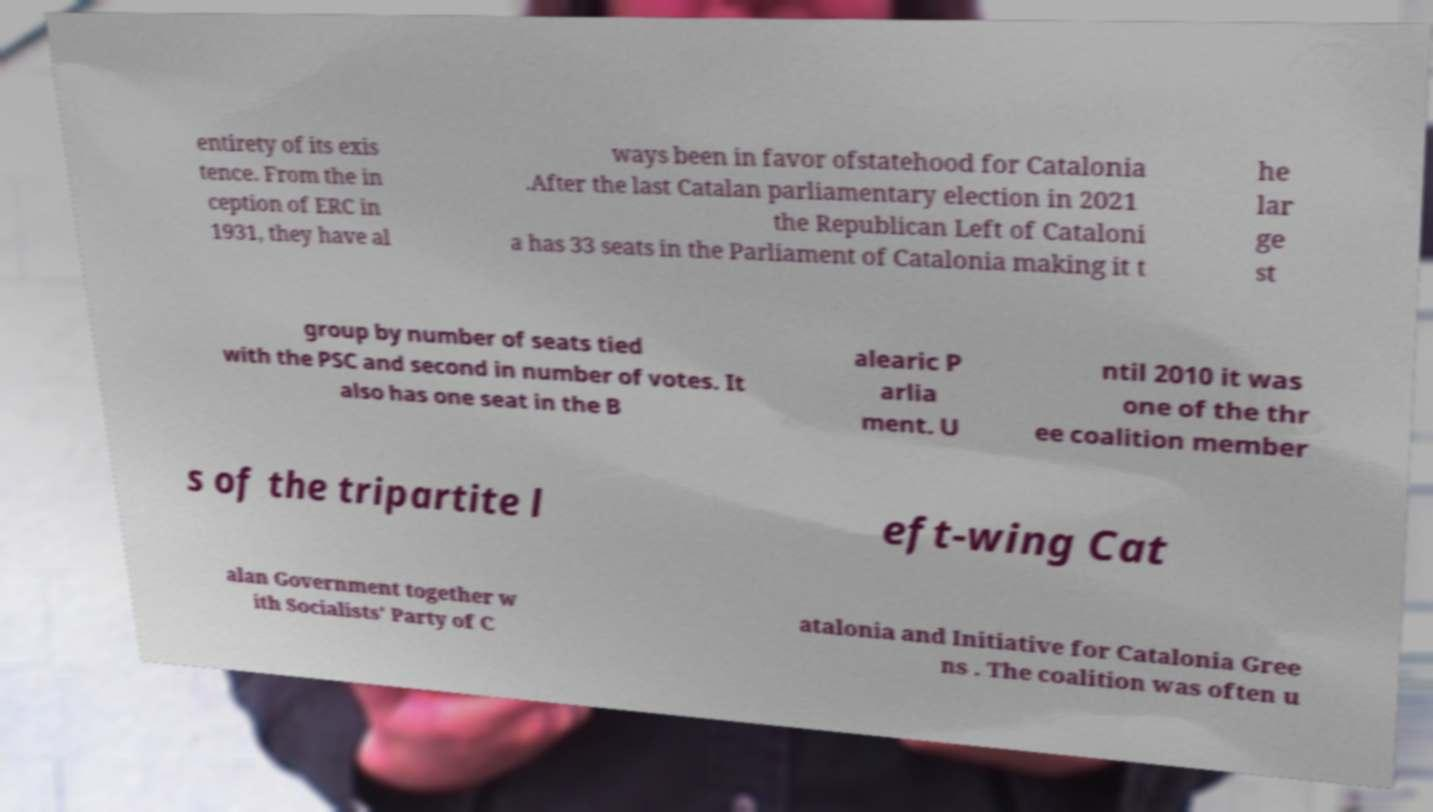Could you assist in decoding the text presented in this image and type it out clearly? entirety of its exis tence. From the in ception of ERC in 1931, they have al ways been in favor ofstatehood for Catalonia .After the last Catalan parliamentary election in 2021 the Republican Left of Cataloni a has 33 seats in the Parliament of Catalonia making it t he lar ge st group by number of seats tied with the PSC and second in number of votes. It also has one seat in the B alearic P arlia ment. U ntil 2010 it was one of the thr ee coalition member s of the tripartite l eft-wing Cat alan Government together w ith Socialists' Party of C atalonia and Initiative for Catalonia Gree ns . The coalition was often u 